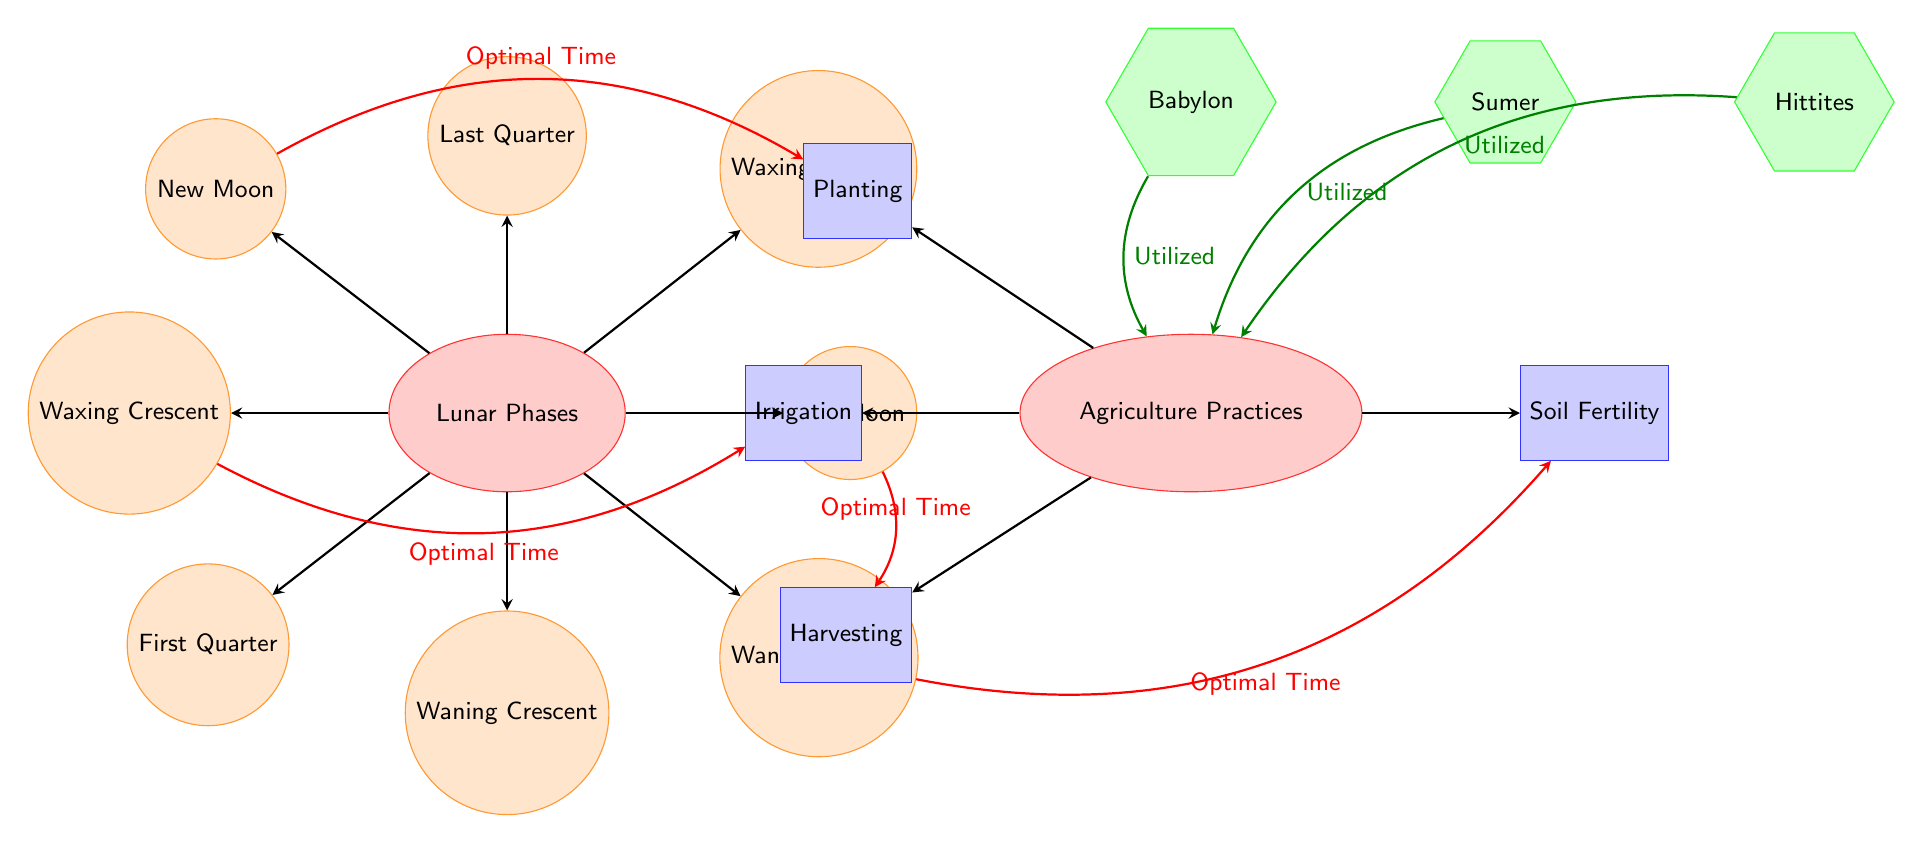What are the four agricultural practices listed in the diagram? The diagram includes four agricultural practices: Planting, Irrigation, Harvesting, and Soil Fertility. These practices are represented as rectangles on the right side of the diagram.
Answer: Planting, Irrigation, Harvesting, Soil Fertility Which lunar phase is indicated as the optimal time for planting? According to the diagram, the New Moon phase is identified as the optimal time for planting, illustrated by a directed arrow from the New Moon node to the Planting node.
Answer: New Moon How many lunar phases are represented in the diagram? There are eight lunar phases illustrated in the diagram: New Moon, Waxing Crescent, First Quarter, Waxing Gibbous, Full Moon, Waning Gibbous, Last Quarter, and Waning Crescent. Counting these nodes gives a total of eight.
Answer: 8 Which ancient empires are indicated as utilizing agricultural practices in the diagram? The diagram specifies three ancient empires that utilized agricultural practices: Babylon, Sumer, and Hittites. These empires are depicted as hexagonal nodes on the top left side of the diagram.
Answer: Babylon, Sumer, Hittites What is the connection between the Full Moon phase and agricultural practices? The diagram shows that the Full Moon phase corresponds with the optimal time for Harvesting. There is a directed and bent arrow from the Full Moon node to the Harvesting node clearly indicating this relationship.
Answer: Harvesting Which lunar phase is linked to soil fertility practices according to the diagram? The diagram connects the Waning Gibbous phase with optimal time for Soil Fertility practices, as indicated by a directed arrow from the Waning Gibbous node to the Soil Fertility node.
Answer: Waning Gibbous What is the total count of nodes representing lunar phases in the diagram? The diagram features eight distinct nodes that represent the lunar phases. This includes individual nodes for New Moon, Waxing Crescent, First Quarter, Waxing Gibbous, Full Moon, Waning Gibbous, Last Quarter, and Waning Crescent.
Answer: 8 Which agricultural practice is optimal during the Waxing Crescent phase? The diagram does not explicitly mention an optimal time for a specific agricultural practice during the Waxing Crescent phase; instead, it shows a direct arrow leading to the Irrigation practice indicating that this lunar phase may be relevant for irrigation.
Answer: Irrigation 